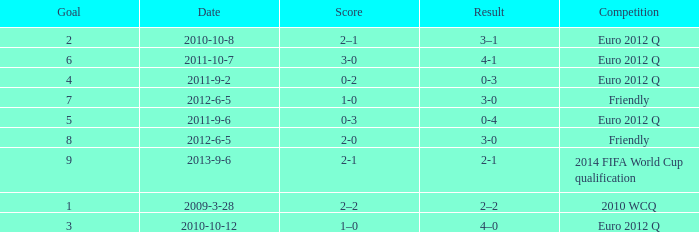How many goals when the score is 3-0 in the euro 2012 q? 1.0. 